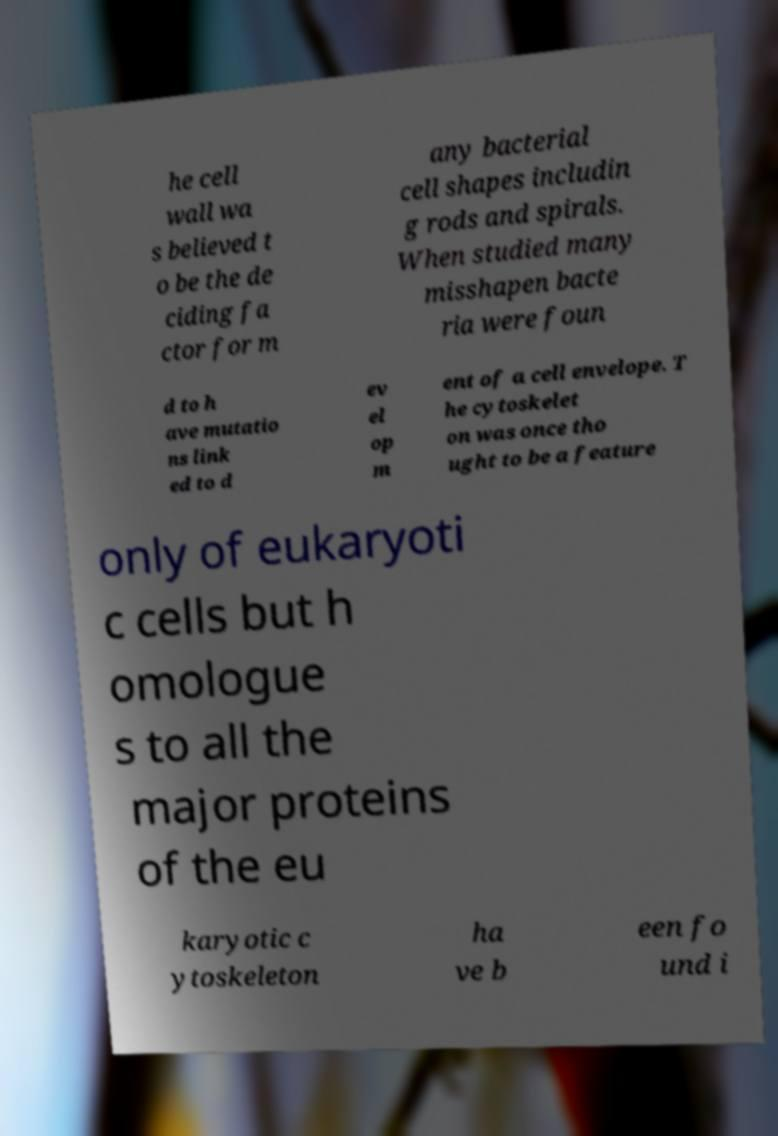Please identify and transcribe the text found in this image. he cell wall wa s believed t o be the de ciding fa ctor for m any bacterial cell shapes includin g rods and spirals. When studied many misshapen bacte ria were foun d to h ave mutatio ns link ed to d ev el op m ent of a cell envelope. T he cytoskelet on was once tho ught to be a feature only of eukaryoti c cells but h omologue s to all the major proteins of the eu karyotic c ytoskeleton ha ve b een fo und i 